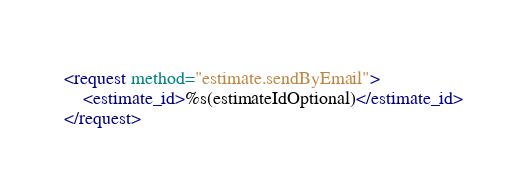<code> <loc_0><loc_0><loc_500><loc_500><_XML_><request method="estimate.sendByEmail">
	<estimate_id>%s(estimateIdOptional)</estimate_id>
</request>
</code> 